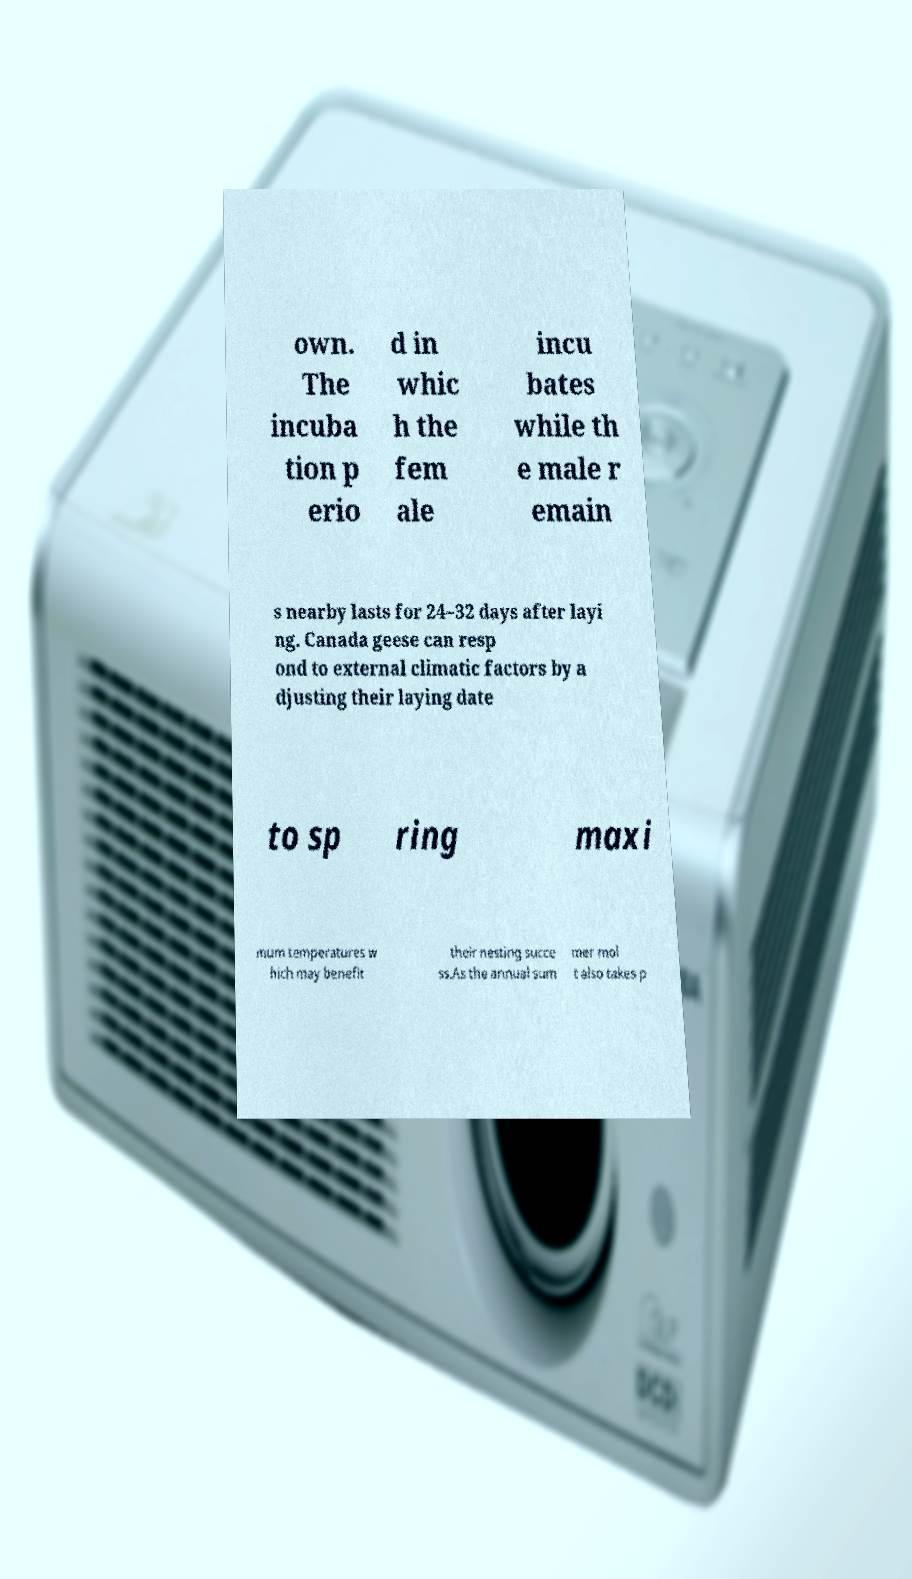Can you accurately transcribe the text from the provided image for me? own. The incuba tion p erio d in whic h the fem ale incu bates while th e male r emain s nearby lasts for 24–32 days after layi ng. Canada geese can resp ond to external climatic factors by a djusting their laying date to sp ring maxi mum temperatures w hich may benefit their nesting succe ss.As the annual sum mer mol t also takes p 